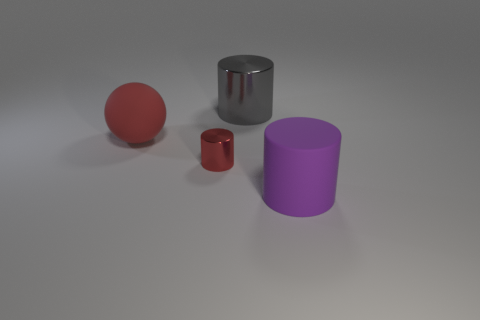There is another thing that is made of the same material as the purple object; what is its color? The material that resembles the purple object's appears to be a metallic surface, similar to one of the cylinders in the image. However, the color of the metallic cylinder is not purple; it is silver. There is no object identical in both material and color to the purple object in this image. 